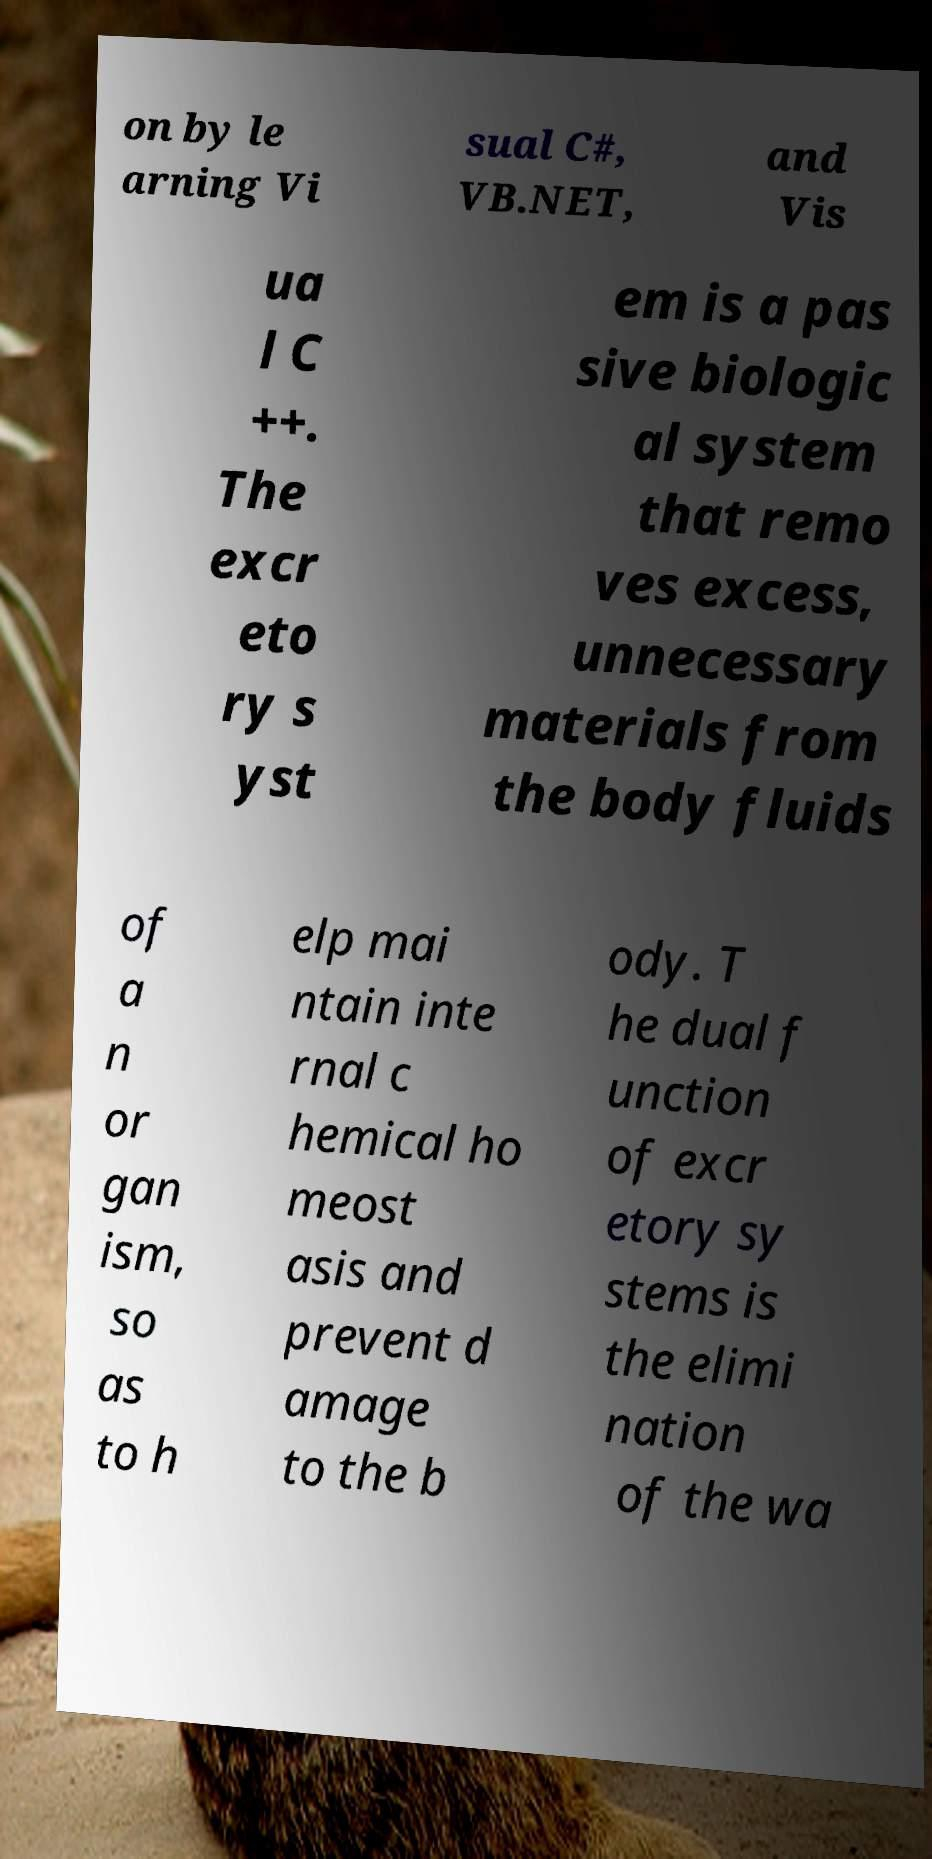Could you extract and type out the text from this image? on by le arning Vi sual C#, VB.NET, and Vis ua l C ++. The excr eto ry s yst em is a pas sive biologic al system that remo ves excess, unnecessary materials from the body fluids of a n or gan ism, so as to h elp mai ntain inte rnal c hemical ho meost asis and prevent d amage to the b ody. T he dual f unction of excr etory sy stems is the elimi nation of the wa 